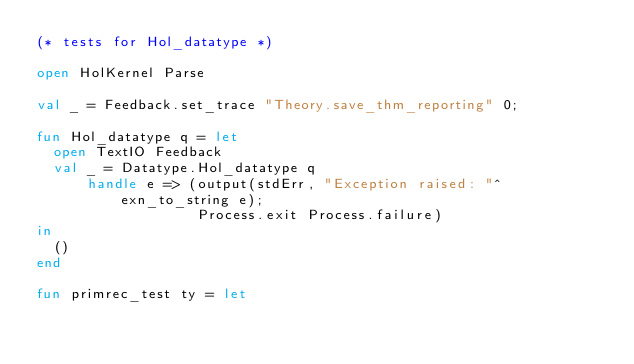Convert code to text. <code><loc_0><loc_0><loc_500><loc_500><_SML_>(* tests for Hol_datatype *)

open HolKernel Parse

val _ = Feedback.set_trace "Theory.save_thm_reporting" 0;

fun Hol_datatype q = let
  open TextIO Feedback
  val _ = Datatype.Hol_datatype q
      handle e => (output(stdErr, "Exception raised: "^exn_to_string e);
                   Process.exit Process.failure)
in
  ()
end

fun primrec_test ty = let</code> 